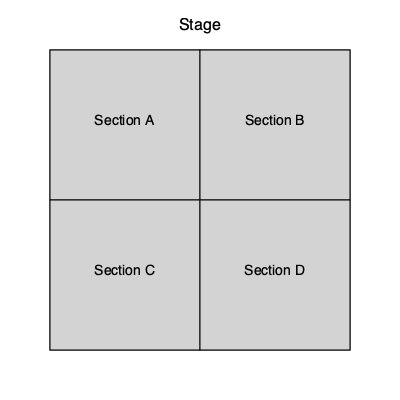At a Goo Goo Dolls concert, you're given an overhead view of the venue as shown above. Each section (A, B, C, and D) can hold 500 people when fully occupied. If sections A and C are completely full, section B is 80% full, and section D is 60% full, estimate the total number of people attending the concert. To estimate the total number of people attending the concert, we need to calculate the occupancy of each section and then sum them up:

1. Section A: Fully occupied
   $500 \times 100\% = 500$ people

2. Section C: Fully occupied
   $500 \times 100\% = 500$ people

3. Section B: 80% full
   $500 \times 80\% = 500 \times 0.8 = 400$ people

4. Section D: 60% full
   $500 \times 60\% = 500 \times 0.6 = 300$ people

5. Total attendance:
   $500 + 500 + 400 + 300 = 1700$ people

Therefore, the estimated total number of people attending the Goo Goo Dolls concert is 1700.
Answer: 1700 people 